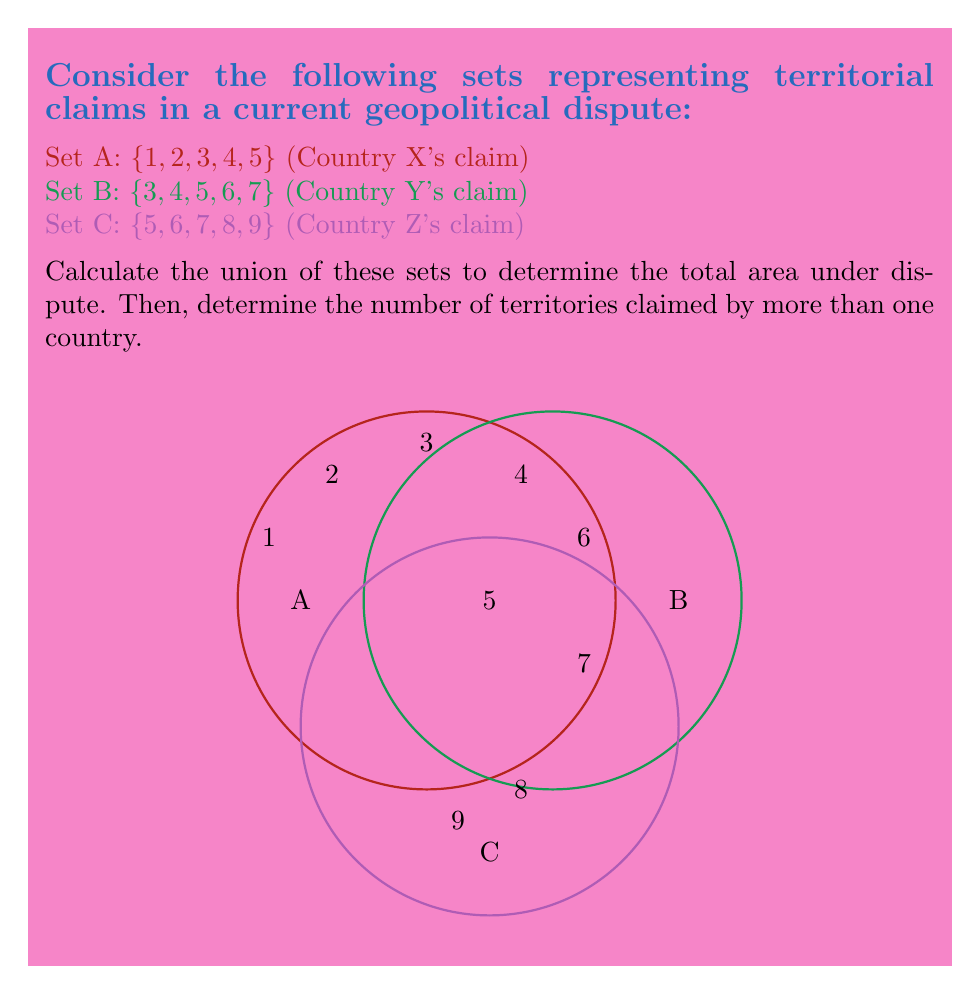What is the answer to this math problem? Let's approach this step-by-step:

1) First, we need to find the union of sets A, B, and C. The union of sets includes all unique elements from all sets. We can represent this mathematically as:

   $$ A \cup B \cup C $$

2) Let's list out all unique elements:
   $$ A \cup B \cup C = \{1, 2, 3, 4, 5, 6, 7, 8, 9\} $$

3) To count the number of elements in this union, we use the cardinality notation:
   $$ |A \cup B \cup C| = 9 $$

4) Now, to find the number of territories claimed by more than one country, we need to identify the intersections:

   A ∩ B = {3, 4, 5}
   B ∩ C = {5, 6, 7}
   A ∩ C = {5}

5) Combining these intersections:
   $$ (A \cap B) \cup (B \cap C) \cup (A \cap C) = \{3, 4, 5, 6, 7\} $$

6) The cardinality of this set gives us the number of territories claimed by more than one country:
   $$ |(A \cap B) \cup (B \cap C) \cup (A \cap C)| = 5 $$

Therefore, the total area under dispute is 9 territories, and 5 of these territories are claimed by more than one country.
Answer: Total area: 9; Multiply claimed: 5 